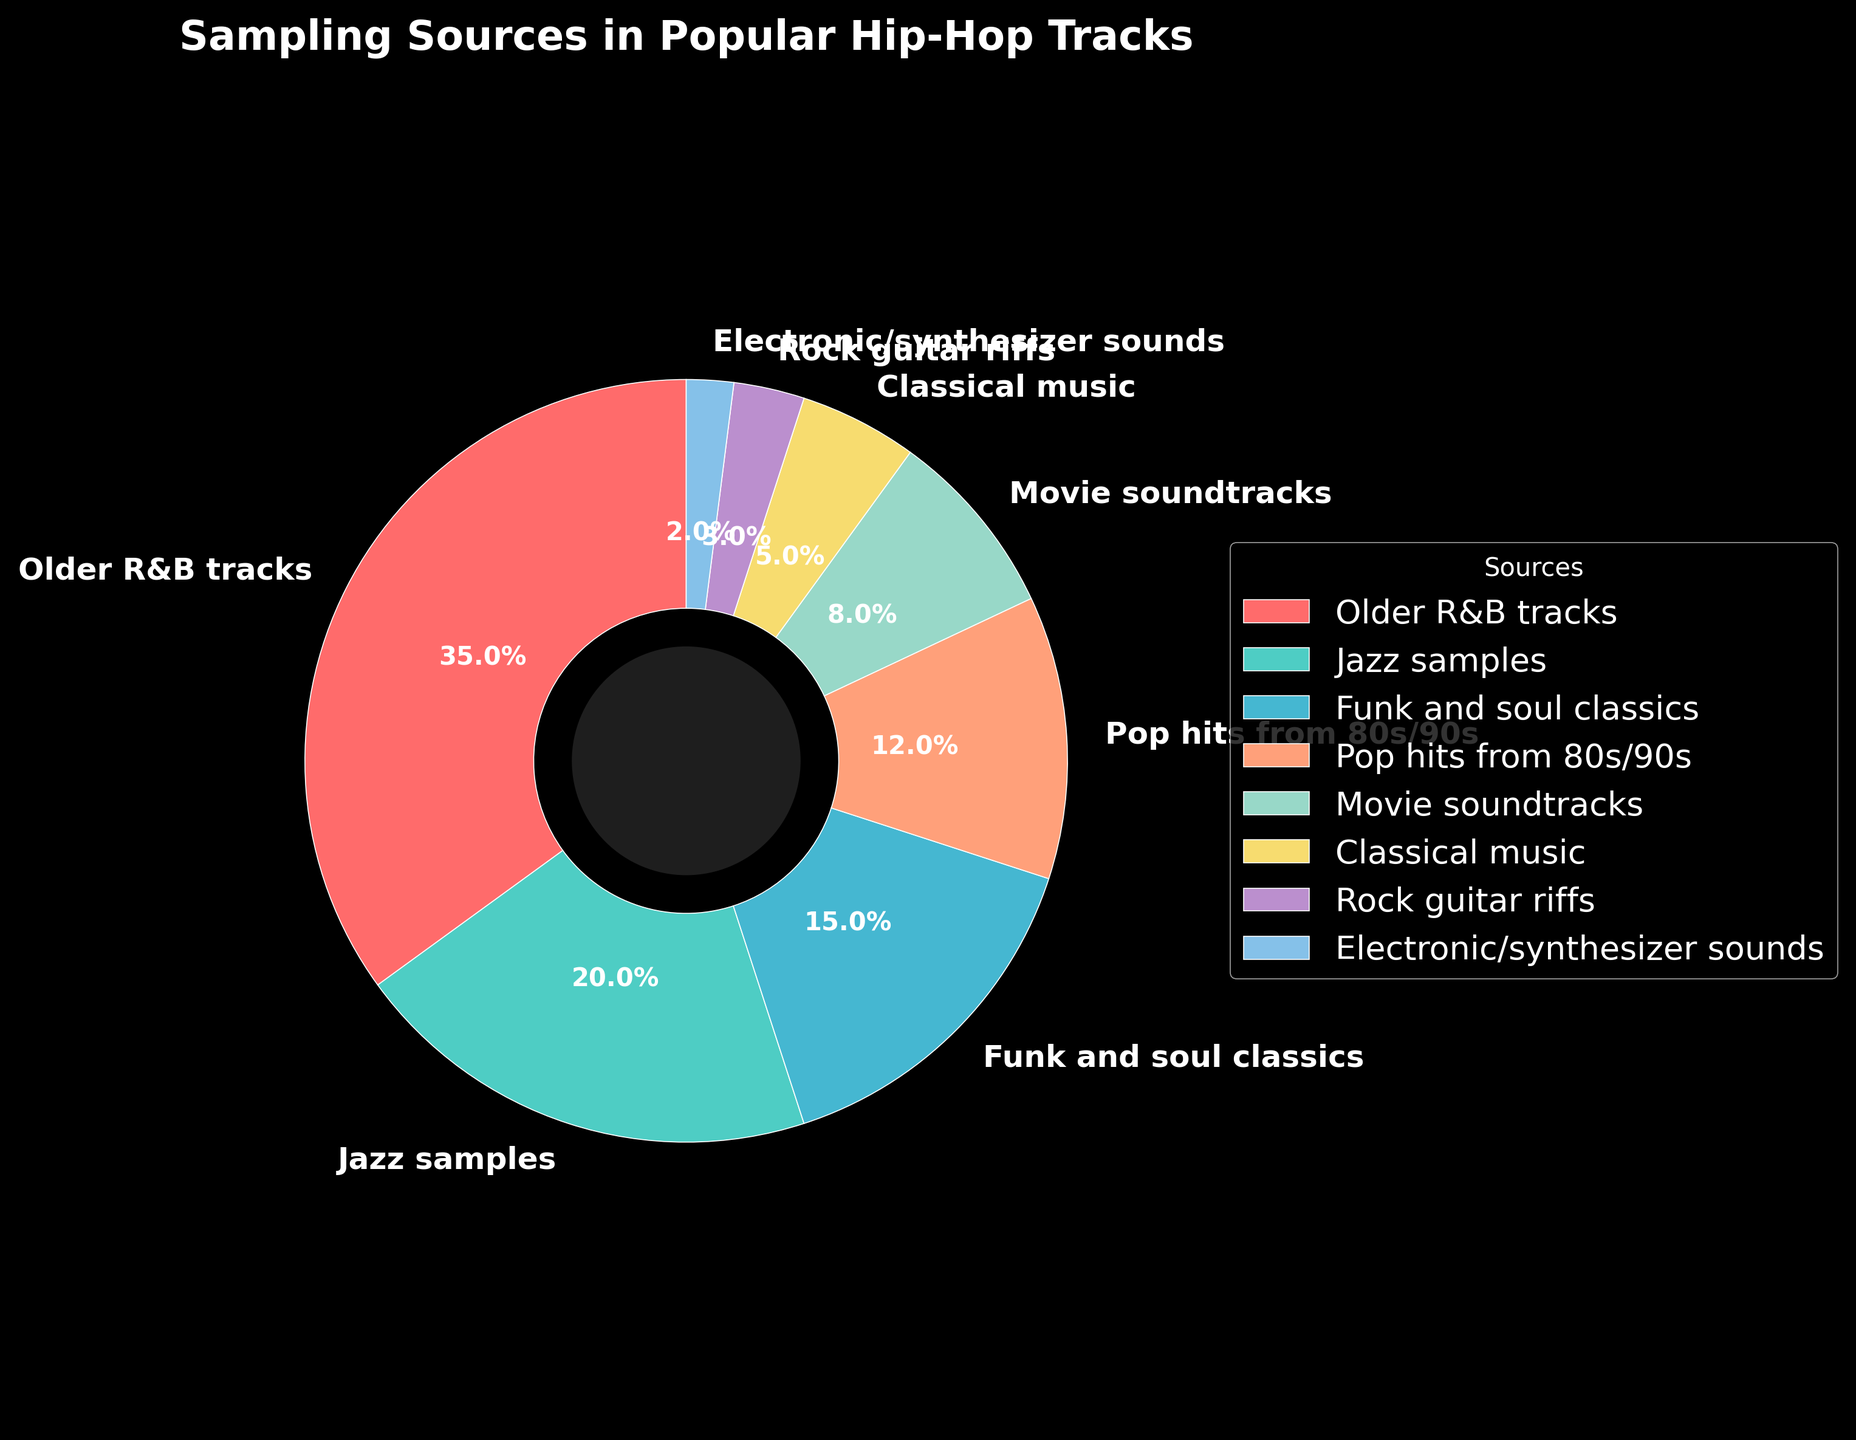What's the most sampled source in popular hip-hop tracks? By looking at the pie chart, the largest slice represents the most sampled source. The label on this slice says "Older R&B tracks" with a percentage of 35%.
Answer: Older R&B tracks What is the sum percentage of Jazz samples and Funk and Soul classics? By identifying the slices labeled "Jazz samples" and "Funk and soul classics," we can see the percentages given for each. Jazz samples are 20%, and Funk and soul classics are 15%. Summing these up, 20% + 15% = 35%.
Answer: 35% Which sampling source makes up the smallest percentage of popular hip-hop tracks? The smallest slice of the pie chart is labeled "Electronic/synthesizer sounds," which is 2%.
Answer: Electronic/synthesizer sounds Is the proportion of Movie soundtracks greater than that of Classical music in the samples? The pie chart shows that Movie soundtracks have an 8% slice, and Classical music has a 5% slice. Since 8% is greater than 5%, the answer is yes.
Answer: Yes What is the combined percentage of all sources sampling directly from music genres (Older R&B tracks, Jazz samples, Funk and soul classics, Pop hits from 80s/90s, Rock guitar riffs)? Adding up the percentages from these categories: 35% (Older R&B) + 20% (Jazz) + 15% (Funk and soul) + 12% (Pop hits) + 3% (Rock) = 85%.
Answer: 85% Which two sampling sources together constitute less than half of the sampling in popular hip-hop tracks? To determine this, we need two categories with a combined percentage of less than 50%. "Electronic/synthesizer sounds" and "Rock guitar riffs" combined are 2% + 3% = 5%, which is less than 50%.
Answer: Electronic/synthesizer sounds and Rock guitar riffs How much more prevalent are Older R&B tracks compared to Pop hits from the 80s/90s? To find this, subtract the percentage of Pop hits from the percentage of Older R&B tracks. Older R&B tracks are 35%, and Pop hits are 12%, so 35% - 12% = 23%.
Answer: 23% What are the three least sampled sources, and what is their total percentage? The three smallest slices correspond to "Electronic/synthesizer sounds," "Rock guitar riffs," and "Classical music," with percentages 2%, 3%, and 5%, respectively. Adding these gives 2% + 3% + 5% = 10%.
Answer: Electronic/synthesizer sounds, Rock guitar riffs, Classical music, 10% By how much do Jazz samples and Funk and soul classics together exceed Movie soundtracks? First, obtain the total percentage of Jazz samples and Funk and soul classics: 20% + 15% = 35%. Then, subtract the percentage of Movie soundtracks: 35% - 8% = 27%.
Answer: 27% 